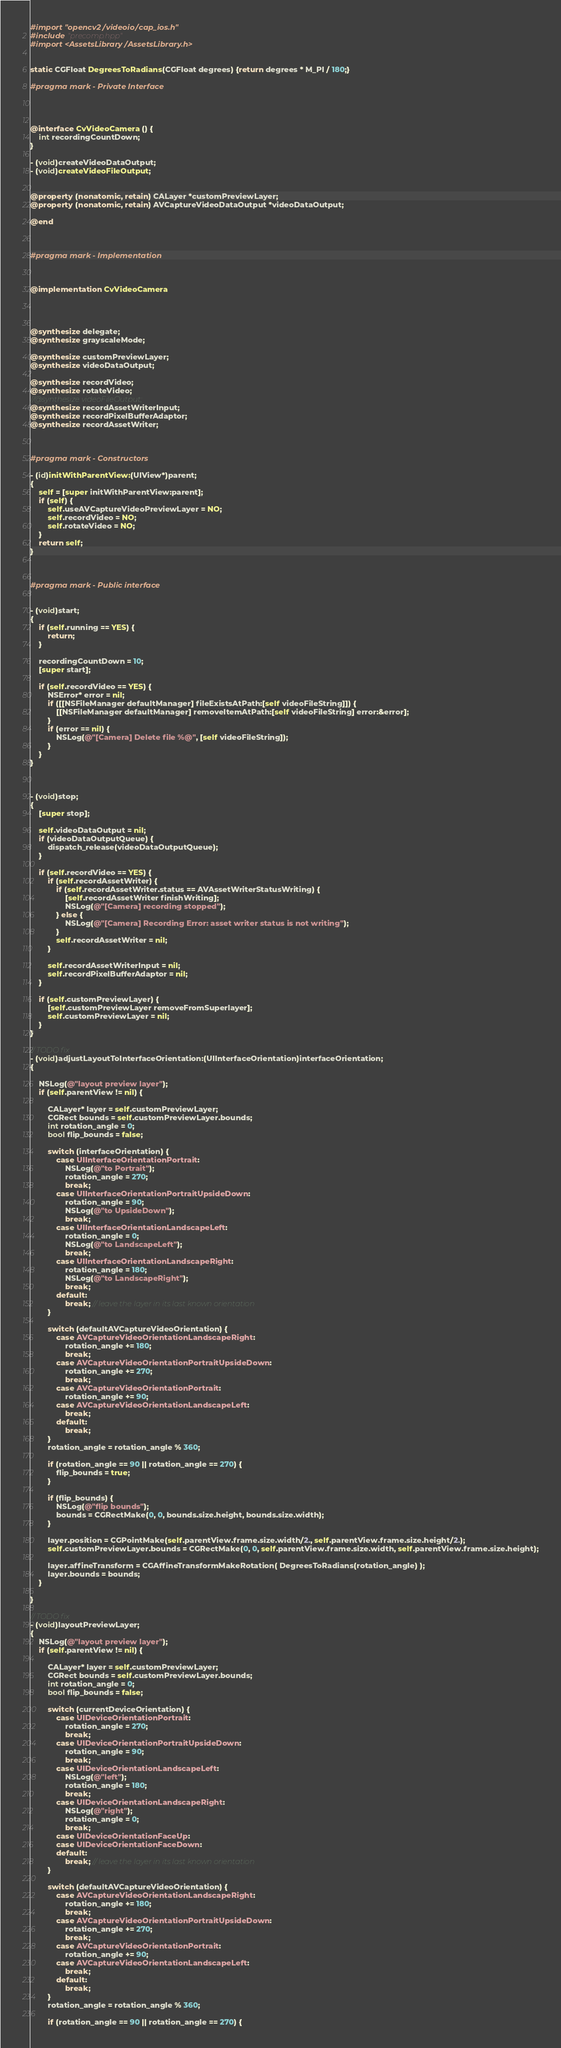<code> <loc_0><loc_0><loc_500><loc_500><_ObjectiveC_>#import "opencv2/videoio/cap_ios.h"
#include "precomp.hpp"
#import <AssetsLibrary/AssetsLibrary.h>


static CGFloat DegreesToRadians(CGFloat degrees) {return degrees * M_PI / 180;}

#pragma mark - Private Interface




@interface CvVideoCamera () {
    int recordingCountDown;
}

- (void)createVideoDataOutput;
- (void)createVideoFileOutput;


@property (nonatomic, retain) CALayer *customPreviewLayer;
@property (nonatomic, retain) AVCaptureVideoDataOutput *videoDataOutput;

@end



#pragma mark - Implementation



@implementation CvVideoCamera




@synthesize delegate;
@synthesize grayscaleMode;

@synthesize customPreviewLayer;
@synthesize videoDataOutput;

@synthesize recordVideo;
@synthesize rotateVideo;
//@synthesize videoFileOutput;
@synthesize recordAssetWriterInput;
@synthesize recordPixelBufferAdaptor;
@synthesize recordAssetWriter;



#pragma mark - Constructors

- (id)initWithParentView:(UIView*)parent;
{
    self = [super initWithParentView:parent];
    if (self) {
        self.useAVCaptureVideoPreviewLayer = NO;
        self.recordVideo = NO;
        self.rotateVideo = NO;
    }
    return self;
}



#pragma mark - Public interface


- (void)start;
{
    if (self.running == YES) {
        return;
    }

    recordingCountDown = 10;
    [super start];

    if (self.recordVideo == YES) {
        NSError* error = nil;
        if ([[NSFileManager defaultManager] fileExistsAtPath:[self videoFileString]]) {
            [[NSFileManager defaultManager] removeItemAtPath:[self videoFileString] error:&error];
        }
        if (error == nil) {
            NSLog(@"[Camera] Delete file %@", [self videoFileString]);
        }
    }
}



- (void)stop;
{
    [super stop];

    self.videoDataOutput = nil;
    if (videoDataOutputQueue) {
        dispatch_release(videoDataOutputQueue);
    }

    if (self.recordVideo == YES) {
        if (self.recordAssetWriter) {
            if (self.recordAssetWriter.status == AVAssetWriterStatusWriting) {
                [self.recordAssetWriter finishWriting];
                NSLog(@"[Camera] recording stopped");
            } else {
                NSLog(@"[Camera] Recording Error: asset writer status is not writing");
            }
            self.recordAssetWriter = nil;
        }

        self.recordAssetWriterInput = nil;
        self.recordPixelBufferAdaptor = nil;
    }

    if (self.customPreviewLayer) {
        [self.customPreviewLayer removeFromSuperlayer];
        self.customPreviewLayer = nil;
    }
}

// TODO fix
- (void)adjustLayoutToInterfaceOrientation:(UIInterfaceOrientation)interfaceOrientation;
{

    NSLog(@"layout preview layer");
    if (self.parentView != nil) {

        CALayer* layer = self.customPreviewLayer;
        CGRect bounds = self.customPreviewLayer.bounds;
        int rotation_angle = 0;
        bool flip_bounds = false;

        switch (interfaceOrientation) {
            case UIInterfaceOrientationPortrait:
                NSLog(@"to Portrait");
                rotation_angle = 270;
                break;
            case UIInterfaceOrientationPortraitUpsideDown:
                rotation_angle = 90;
                NSLog(@"to UpsideDown");
                break;
            case UIInterfaceOrientationLandscapeLeft:
                rotation_angle = 0;
                NSLog(@"to LandscapeLeft");
                break;
            case UIInterfaceOrientationLandscapeRight:
                rotation_angle = 180;
                NSLog(@"to LandscapeRight");
                break;
            default:
                break; // leave the layer in its last known orientation
        }

        switch (defaultAVCaptureVideoOrientation) {
            case AVCaptureVideoOrientationLandscapeRight:
                rotation_angle += 180;
                break;
            case AVCaptureVideoOrientationPortraitUpsideDown:
                rotation_angle += 270;
                break;
            case AVCaptureVideoOrientationPortrait:
                rotation_angle += 90;
            case AVCaptureVideoOrientationLandscapeLeft:
                break;
            default:
                break;
        }
        rotation_angle = rotation_angle % 360;

        if (rotation_angle == 90 || rotation_angle == 270) {
            flip_bounds = true;
        }

        if (flip_bounds) {
            NSLog(@"flip bounds");
            bounds = CGRectMake(0, 0, bounds.size.height, bounds.size.width);
        }

        layer.position = CGPointMake(self.parentView.frame.size.width/2., self.parentView.frame.size.height/2.);
        self.customPreviewLayer.bounds = CGRectMake(0, 0, self.parentView.frame.size.width, self.parentView.frame.size.height);

        layer.affineTransform = CGAffineTransformMakeRotation( DegreesToRadians(rotation_angle) );
        layer.bounds = bounds;
    }

}

// TODO fix
- (void)layoutPreviewLayer;
{
    NSLog(@"layout preview layer");
    if (self.parentView != nil) {

        CALayer* layer = self.customPreviewLayer;
        CGRect bounds = self.customPreviewLayer.bounds;
        int rotation_angle = 0;
        bool flip_bounds = false;

        switch (currentDeviceOrientation) {
            case UIDeviceOrientationPortrait:
                rotation_angle = 270;
                break;
            case UIDeviceOrientationPortraitUpsideDown:
                rotation_angle = 90;
                break;
            case UIDeviceOrientationLandscapeLeft:
                NSLog(@"left");
                rotation_angle = 180;
                break;
            case UIDeviceOrientationLandscapeRight:
                NSLog(@"right");
                rotation_angle = 0;
                break;
            case UIDeviceOrientationFaceUp:
            case UIDeviceOrientationFaceDown:
            default:
                break; // leave the layer in its last known orientation
        }

        switch (defaultAVCaptureVideoOrientation) {
            case AVCaptureVideoOrientationLandscapeRight:
                rotation_angle += 180;
                break;
            case AVCaptureVideoOrientationPortraitUpsideDown:
                rotation_angle += 270;
                break;
            case AVCaptureVideoOrientationPortrait:
                rotation_angle += 90;
            case AVCaptureVideoOrientationLandscapeLeft:
                break;
            default:
                break;
        }
        rotation_angle = rotation_angle % 360;

        if (rotation_angle == 90 || rotation_angle == 270) {</code> 